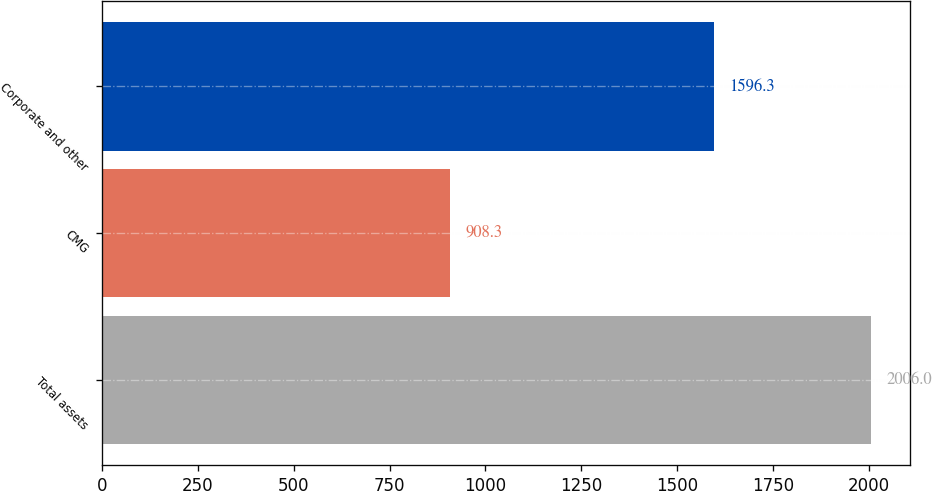<chart> <loc_0><loc_0><loc_500><loc_500><bar_chart><fcel>Total assets<fcel>CMG<fcel>Corporate and other<nl><fcel>2006<fcel>908.3<fcel>1596.3<nl></chart> 